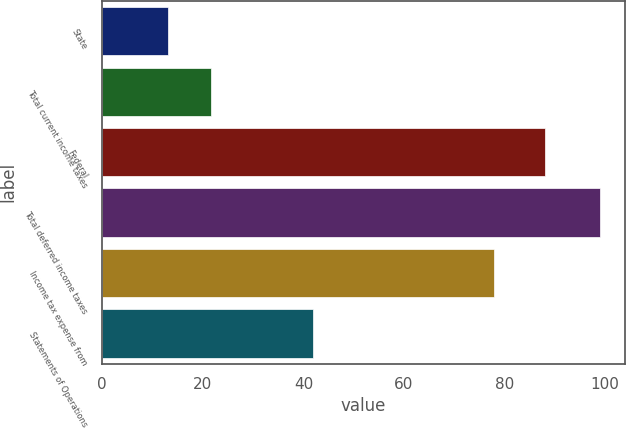<chart> <loc_0><loc_0><loc_500><loc_500><bar_chart><fcel>State<fcel>Total current income taxes<fcel>Federal<fcel>Total deferred income taxes<fcel>Income tax expense from<fcel>Statements of Operations<nl><fcel>13<fcel>21.6<fcel>88<fcel>99<fcel>78<fcel>42<nl></chart> 